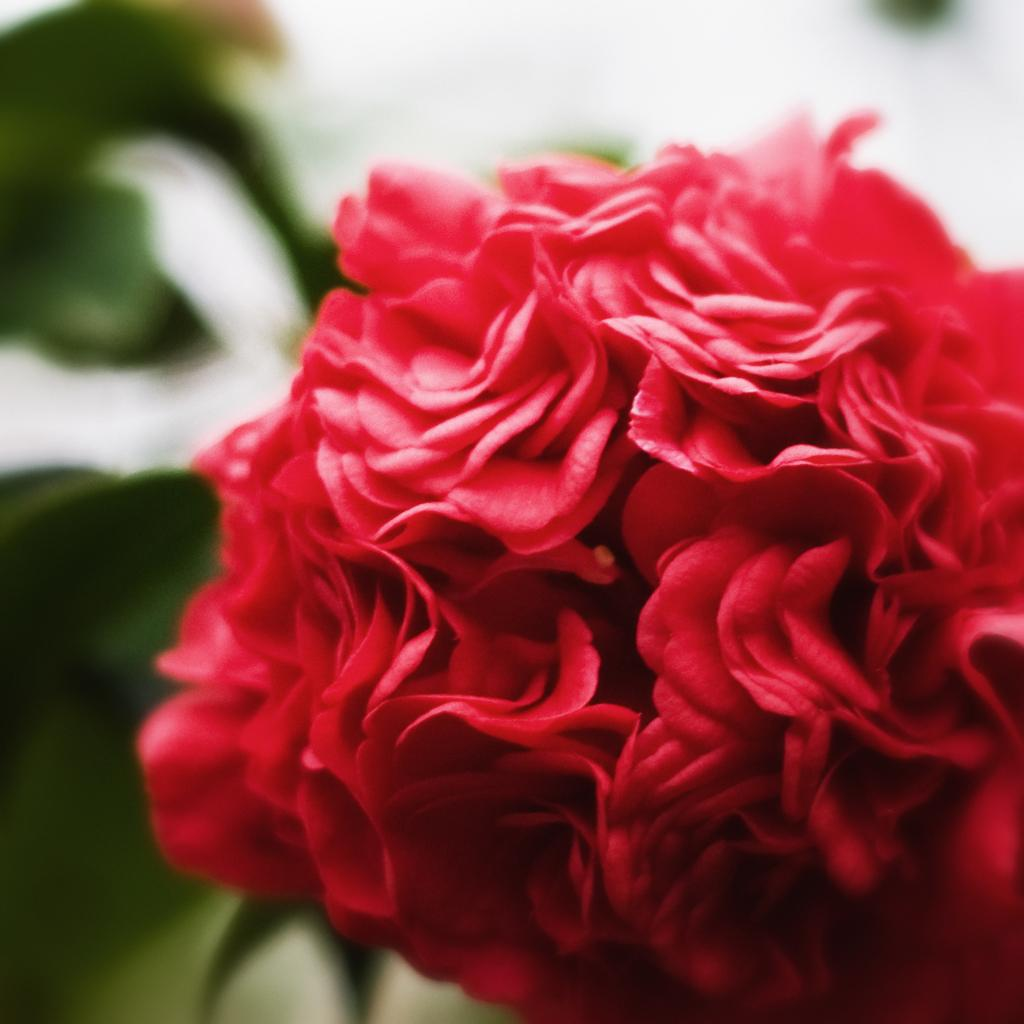What type of flower is in the image? There is a red rose flower in the image. What color are the leaves next to the flower? The leaves to the left of the flower are green. How would you describe the background of the image? The background of the image is blurred. What type of answer is being given in the image? There is no answer being given in the image, as it features a red rose flower and green leaves. What type of spade is being used in the image? There is no spade present in the image. 